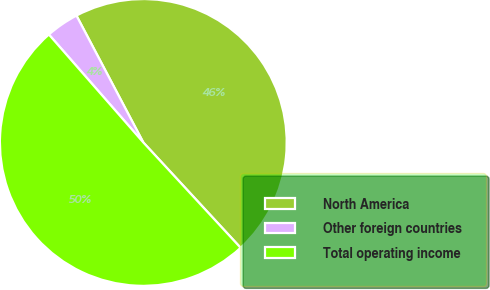Convert chart. <chart><loc_0><loc_0><loc_500><loc_500><pie_chart><fcel>North America<fcel>Other foreign countries<fcel>Total operating income<nl><fcel>45.85%<fcel>3.72%<fcel>50.43%<nl></chart> 